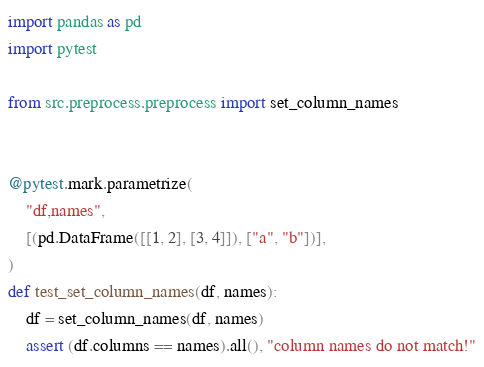<code> <loc_0><loc_0><loc_500><loc_500><_Python_>import pandas as pd
import pytest

from src.preprocess.preprocess import set_column_names


@pytest.mark.parametrize(
    "df,names",
    [(pd.DataFrame([[1, 2], [3, 4]]), ["a", "b"])],
)
def test_set_column_names(df, names):
    df = set_column_names(df, names)
    assert (df.columns == names).all(), "column names do not match!"
</code> 